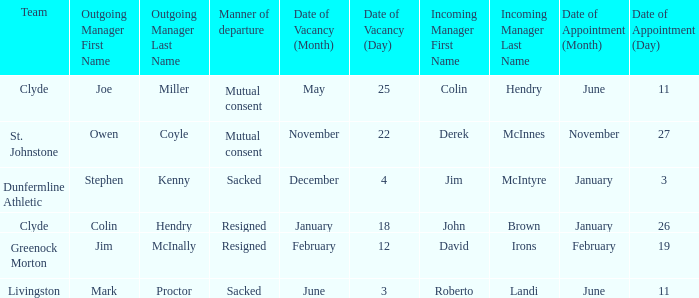Name the manner of departyre for 26 january date of appointment Resigned. 